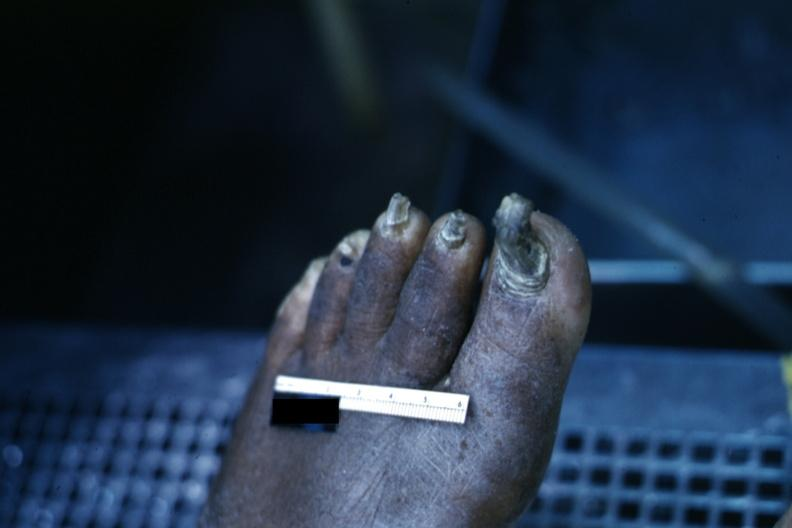s slices of liver and spleen typical tuberculous exudate is present on capsule of liver and spleen present?
Answer the question using a single word or phrase. No 